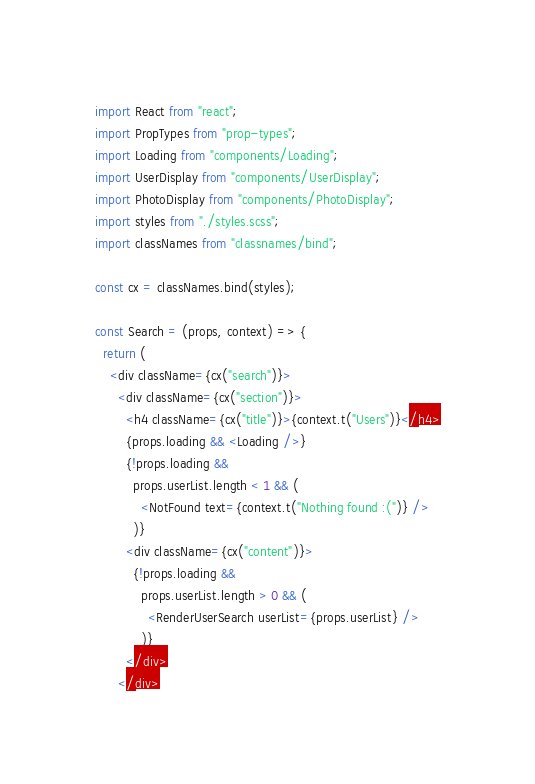<code> <loc_0><loc_0><loc_500><loc_500><_JavaScript_>import React from "react";
import PropTypes from "prop-types";
import Loading from "components/Loading";
import UserDisplay from "components/UserDisplay";
import PhotoDisplay from "components/PhotoDisplay";
import styles from "./styles.scss";
import classNames from "classnames/bind";

const cx = classNames.bind(styles);

const Search = (props, context) => {
  return (
    <div className={cx("search")}>
      <div className={cx("section")}>
        <h4 className={cx("title")}>{context.t("Users")}</h4>
        {props.loading && <Loading />}
        {!props.loading &&
          props.userList.length < 1 && (
            <NotFound text={context.t("Nothing found :(")} />
          )}
        <div className={cx("content")}>
          {!props.loading &&
            props.userList.length > 0 && (
              <RenderUserSearch userList={props.userList} />
            )}
        </div>
      </div></code> 